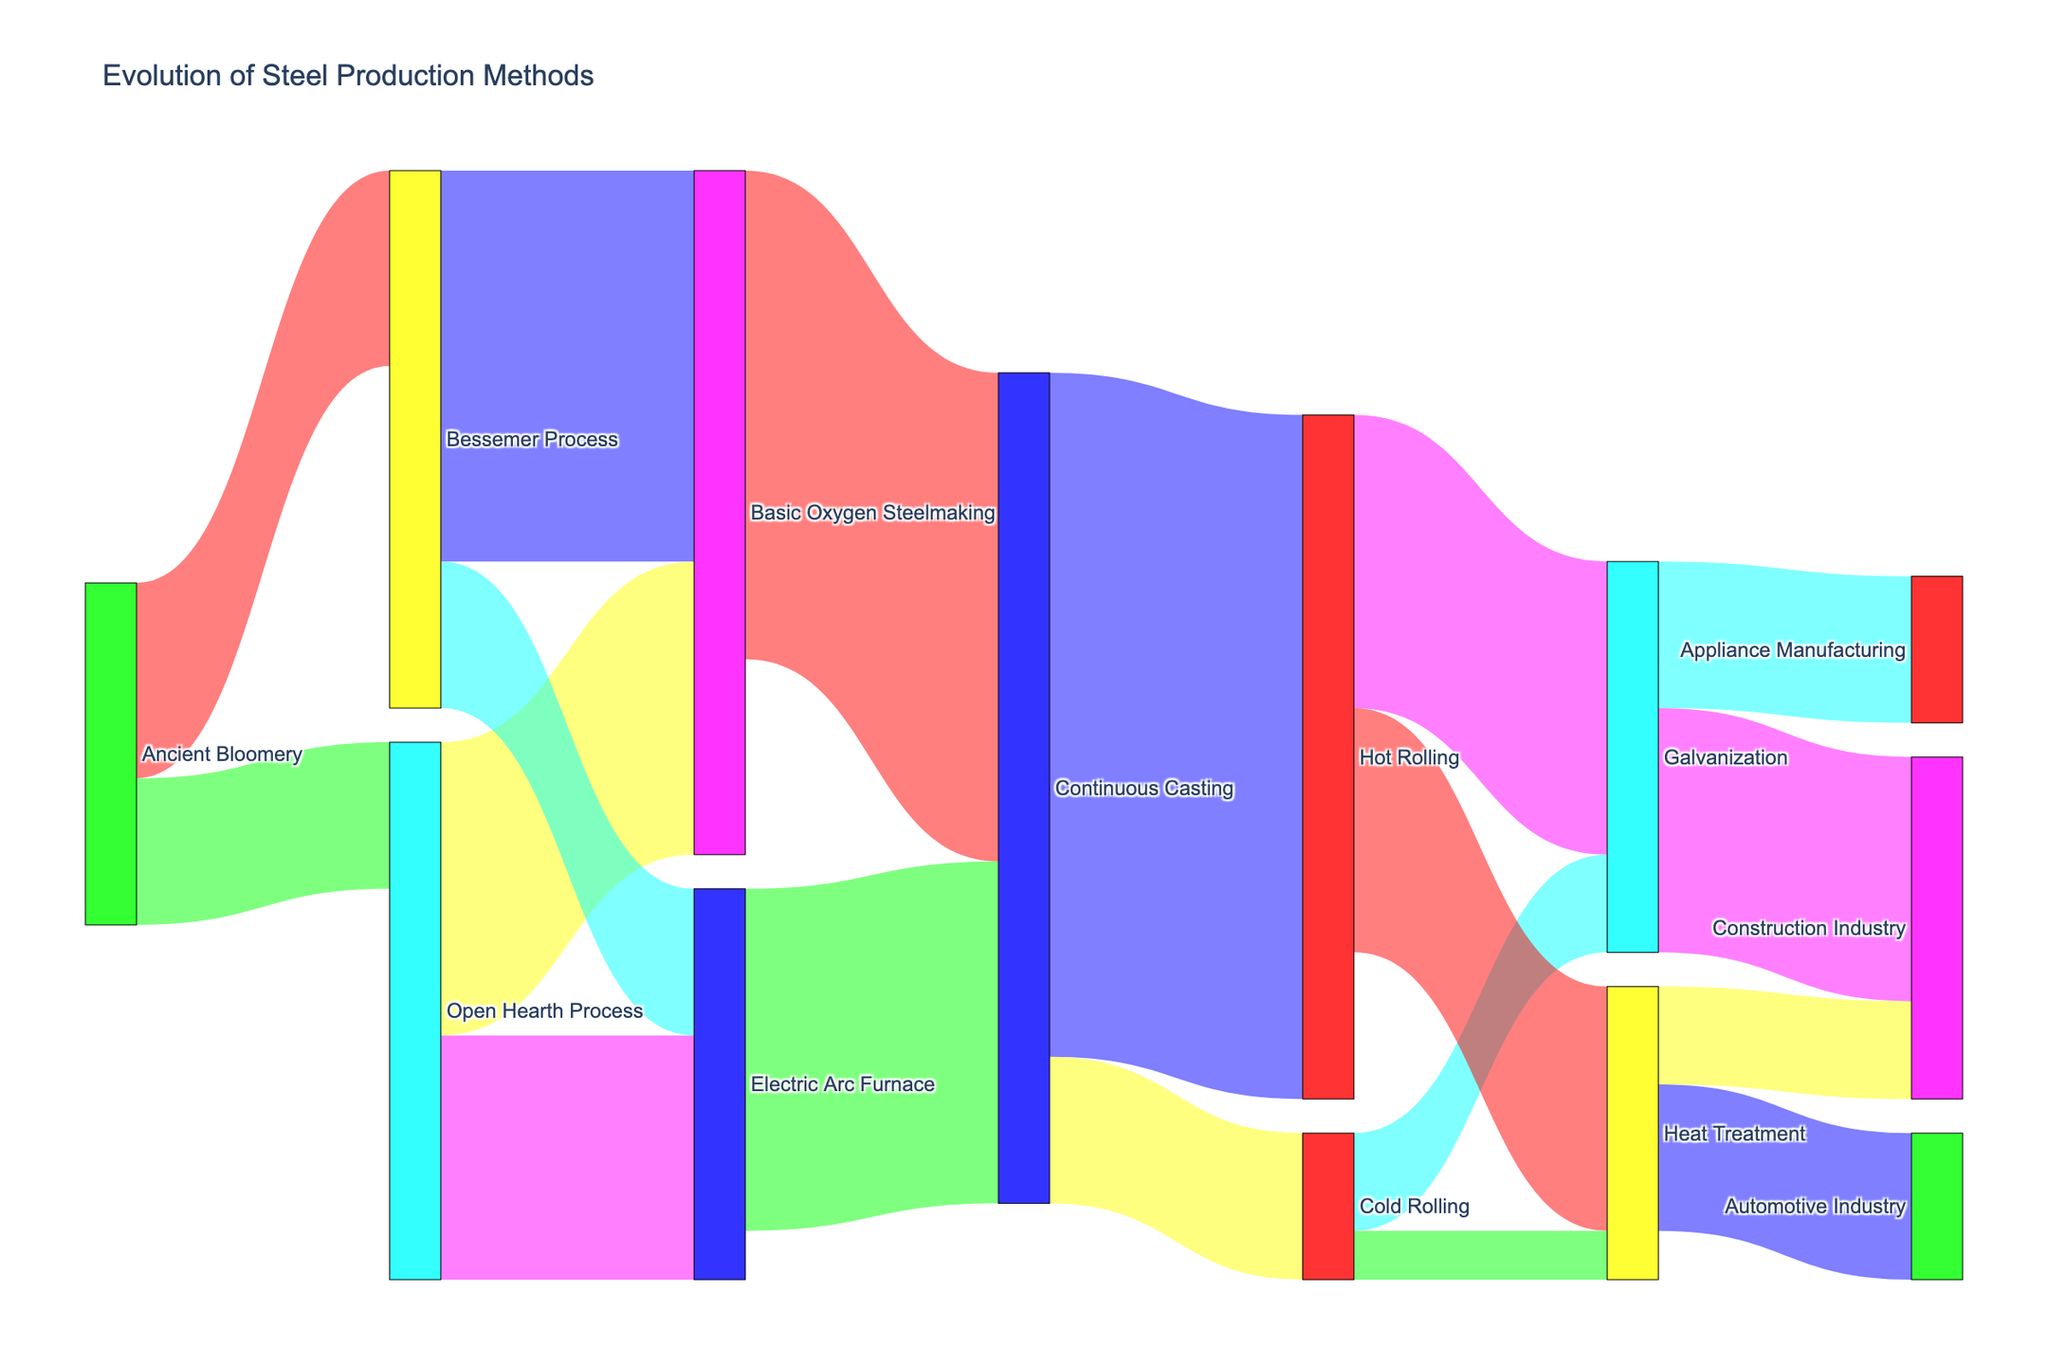How many steel production methods are shown in the figure? Count the unique nodes labeled with different processes or techniques in the Sankey diagram.
Answer: 11 Which steel production method has the highest value flowing into Continuous Casting? Observe the values of the links flowing into Continuous Casting and identify the highest one. Basic Oxygen Steelmaking to Continuous Casting has a value of 50, and Electric Arc Furnace to Continuous Casting has a value of 35. The highest is 50.
Answer: Basic Oxygen Steelmaking How much total value flows out of the Open Hearth Process? Sum the values of all links that start from the Open Hearth Process. These are 30 (to Basic Oxygen Steelmaking) and 25 (to Electric Arc Furnace). The total is 30 + 25 = 55.
Answer: 55 What’s the difference in value between the flows from Basic Oxygen Steelmaking to Continuous Casting and from Electric Arc Furnace to Continuous Casting? Subtract the smaller value from the larger value among the two flows. The values are 50 (from Basic Oxygen Steelmaking) and 35 (from Electric Arc Furnace). The difference is 50 - 35 = 15.
Answer: 15 Which industry receives more value from Galvanization: Construction or Appliance Manufacturing? Compare the outgoing values from Galvanization to both industries. To Construction Industry is 25 and to Appliance Manufacturing is 15. Construction Industry receives more.
Answer: Construction Industry What is the total value flowing into the Heat Treatment process? Sum the values of all links pointing to Heat Treatment. These are 25 (from Hot Rolling) and 5 (from Cold Rolling). The total is 25 + 5 = 30.
Answer: 30 Which production process was adopted by both Bessemer Process and Open Hearth Process? Find the target node that is connected to both the Bessemer Process and the Open Hearth Process. Basic Oxygen Steelmaking is connected to both.
Answer: Basic Oxygen Steelmaking How much value flows from Continuous Casting to both Hot Rolling and Cold Rolling combined? Add the values of the links from Continuous Casting to Hot Rolling and Cold Rolling. These are 70 (to Hot Rolling) and 15 (to Cold Rolling). The total is 70 + 15 = 85.
Answer: 85 Which steel production method originating from the Bessemer Process has the least value? Compare the values of links originating from the Bessemer Process. To Basic Oxygen Steelmaking is 40, and to Electric Arc Furnace is 15. The least is 15.
Answer: Electric Arc Furnace 